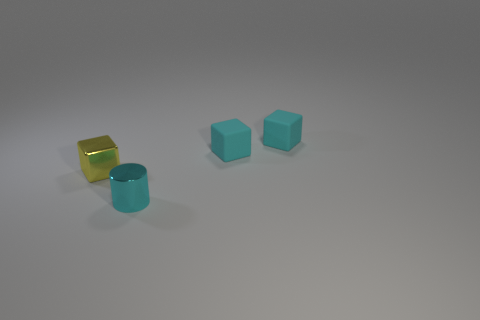There is a small cyan thing in front of the small yellow metallic block; what shape is it?
Your answer should be very brief. Cylinder. Are any tiny red rubber things visible?
Provide a short and direct response. No. The tiny shiny object right of the tiny block on the left side of the metal object that is on the right side of the small yellow shiny object is what shape?
Provide a short and direct response. Cylinder. What number of cyan matte cubes are right of the small cyan metal object?
Make the answer very short. 2. How many other objects are there of the same shape as the cyan metallic thing?
Keep it short and to the point. 0. What number of cyan matte cubes are behind the small shiny object to the right of the metallic object that is on the left side of the cyan metallic object?
Provide a succinct answer. 2. What color is the thing left of the small metallic cylinder?
Ensure brevity in your answer.  Yellow. Is there anything else that has the same size as the yellow metal cube?
Provide a short and direct response. Yes. What material is the tiny thing in front of the tiny metal thing left of the small object that is in front of the metallic block?
Ensure brevity in your answer.  Metal. Is the number of small matte cubes that are behind the yellow metallic object greater than the number of tiny cyan metallic cylinders that are to the right of the cyan shiny cylinder?
Offer a very short reply. Yes. 